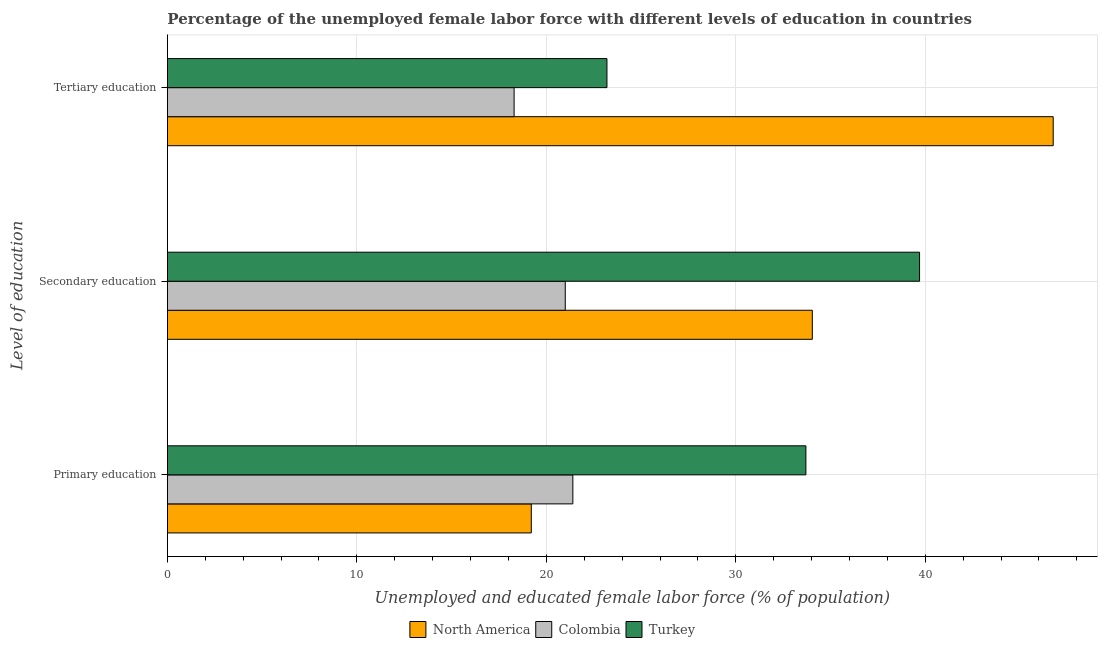How many groups of bars are there?
Your response must be concise. 3. Are the number of bars per tick equal to the number of legend labels?
Provide a short and direct response. Yes. Are the number of bars on each tick of the Y-axis equal?
Your answer should be compact. Yes. What is the label of the 2nd group of bars from the top?
Provide a short and direct response. Secondary education. What is the percentage of female labor force who received tertiary education in North America?
Keep it short and to the point. 46.75. Across all countries, what is the maximum percentage of female labor force who received secondary education?
Make the answer very short. 39.7. Across all countries, what is the minimum percentage of female labor force who received primary education?
Ensure brevity in your answer.  19.21. What is the total percentage of female labor force who received tertiary education in the graph?
Give a very brief answer. 88.25. What is the difference between the percentage of female labor force who received primary education in Colombia and that in North America?
Offer a terse response. 2.19. What is the difference between the percentage of female labor force who received secondary education in North America and the percentage of female labor force who received primary education in Colombia?
Your answer should be compact. 12.64. What is the average percentage of female labor force who received tertiary education per country?
Your response must be concise. 29.42. What is the difference between the percentage of female labor force who received secondary education and percentage of female labor force who received tertiary education in Turkey?
Provide a short and direct response. 16.5. In how many countries, is the percentage of female labor force who received tertiary education greater than 8 %?
Ensure brevity in your answer.  3. What is the ratio of the percentage of female labor force who received secondary education in North America to that in Turkey?
Make the answer very short. 0.86. Is the difference between the percentage of female labor force who received secondary education in Colombia and North America greater than the difference between the percentage of female labor force who received tertiary education in Colombia and North America?
Your answer should be compact. Yes. What is the difference between the highest and the second highest percentage of female labor force who received primary education?
Your response must be concise. 12.3. What is the difference between the highest and the lowest percentage of female labor force who received primary education?
Provide a short and direct response. 14.49. Is the sum of the percentage of female labor force who received secondary education in North America and Colombia greater than the maximum percentage of female labor force who received tertiary education across all countries?
Make the answer very short. Yes. What does the 1st bar from the bottom in Secondary education represents?
Offer a very short reply. North America. How are the legend labels stacked?
Provide a short and direct response. Horizontal. What is the title of the graph?
Provide a short and direct response. Percentage of the unemployed female labor force with different levels of education in countries. Does "Upper middle income" appear as one of the legend labels in the graph?
Provide a succinct answer. No. What is the label or title of the X-axis?
Ensure brevity in your answer.  Unemployed and educated female labor force (% of population). What is the label or title of the Y-axis?
Make the answer very short. Level of education. What is the Unemployed and educated female labor force (% of population) in North America in Primary education?
Provide a short and direct response. 19.21. What is the Unemployed and educated female labor force (% of population) in Colombia in Primary education?
Your answer should be very brief. 21.4. What is the Unemployed and educated female labor force (% of population) of Turkey in Primary education?
Make the answer very short. 33.7. What is the Unemployed and educated female labor force (% of population) of North America in Secondary education?
Offer a terse response. 34.04. What is the Unemployed and educated female labor force (% of population) in Colombia in Secondary education?
Provide a short and direct response. 21. What is the Unemployed and educated female labor force (% of population) of Turkey in Secondary education?
Your response must be concise. 39.7. What is the Unemployed and educated female labor force (% of population) in North America in Tertiary education?
Provide a short and direct response. 46.75. What is the Unemployed and educated female labor force (% of population) of Colombia in Tertiary education?
Your answer should be compact. 18.3. What is the Unemployed and educated female labor force (% of population) of Turkey in Tertiary education?
Your answer should be very brief. 23.2. Across all Level of education, what is the maximum Unemployed and educated female labor force (% of population) in North America?
Your answer should be very brief. 46.75. Across all Level of education, what is the maximum Unemployed and educated female labor force (% of population) in Colombia?
Provide a short and direct response. 21.4. Across all Level of education, what is the maximum Unemployed and educated female labor force (% of population) in Turkey?
Your answer should be compact. 39.7. Across all Level of education, what is the minimum Unemployed and educated female labor force (% of population) of North America?
Provide a succinct answer. 19.21. Across all Level of education, what is the minimum Unemployed and educated female labor force (% of population) in Colombia?
Your response must be concise. 18.3. Across all Level of education, what is the minimum Unemployed and educated female labor force (% of population) of Turkey?
Provide a short and direct response. 23.2. What is the total Unemployed and educated female labor force (% of population) of Colombia in the graph?
Your answer should be very brief. 60.7. What is the total Unemployed and educated female labor force (% of population) of Turkey in the graph?
Ensure brevity in your answer.  96.6. What is the difference between the Unemployed and educated female labor force (% of population) in North America in Primary education and that in Secondary education?
Give a very brief answer. -14.83. What is the difference between the Unemployed and educated female labor force (% of population) of North America in Primary education and that in Tertiary education?
Your answer should be compact. -27.55. What is the difference between the Unemployed and educated female labor force (% of population) in Colombia in Primary education and that in Tertiary education?
Your answer should be compact. 3.1. What is the difference between the Unemployed and educated female labor force (% of population) of North America in Secondary education and that in Tertiary education?
Offer a very short reply. -12.71. What is the difference between the Unemployed and educated female labor force (% of population) in Colombia in Secondary education and that in Tertiary education?
Offer a terse response. 2.7. What is the difference between the Unemployed and educated female labor force (% of population) in North America in Primary education and the Unemployed and educated female labor force (% of population) in Colombia in Secondary education?
Provide a short and direct response. -1.79. What is the difference between the Unemployed and educated female labor force (% of population) of North America in Primary education and the Unemployed and educated female labor force (% of population) of Turkey in Secondary education?
Give a very brief answer. -20.49. What is the difference between the Unemployed and educated female labor force (% of population) of Colombia in Primary education and the Unemployed and educated female labor force (% of population) of Turkey in Secondary education?
Make the answer very short. -18.3. What is the difference between the Unemployed and educated female labor force (% of population) of North America in Primary education and the Unemployed and educated female labor force (% of population) of Colombia in Tertiary education?
Give a very brief answer. 0.91. What is the difference between the Unemployed and educated female labor force (% of population) of North America in Primary education and the Unemployed and educated female labor force (% of population) of Turkey in Tertiary education?
Your response must be concise. -3.99. What is the difference between the Unemployed and educated female labor force (% of population) in Colombia in Primary education and the Unemployed and educated female labor force (% of population) in Turkey in Tertiary education?
Offer a very short reply. -1.8. What is the difference between the Unemployed and educated female labor force (% of population) in North America in Secondary education and the Unemployed and educated female labor force (% of population) in Colombia in Tertiary education?
Your answer should be very brief. 15.74. What is the difference between the Unemployed and educated female labor force (% of population) in North America in Secondary education and the Unemployed and educated female labor force (% of population) in Turkey in Tertiary education?
Provide a short and direct response. 10.84. What is the average Unemployed and educated female labor force (% of population) in North America per Level of education?
Your response must be concise. 33.33. What is the average Unemployed and educated female labor force (% of population) in Colombia per Level of education?
Your response must be concise. 20.23. What is the average Unemployed and educated female labor force (% of population) in Turkey per Level of education?
Your response must be concise. 32.2. What is the difference between the Unemployed and educated female labor force (% of population) of North America and Unemployed and educated female labor force (% of population) of Colombia in Primary education?
Your answer should be very brief. -2.19. What is the difference between the Unemployed and educated female labor force (% of population) in North America and Unemployed and educated female labor force (% of population) in Turkey in Primary education?
Provide a succinct answer. -14.49. What is the difference between the Unemployed and educated female labor force (% of population) in North America and Unemployed and educated female labor force (% of population) in Colombia in Secondary education?
Provide a succinct answer. 13.04. What is the difference between the Unemployed and educated female labor force (% of population) in North America and Unemployed and educated female labor force (% of population) in Turkey in Secondary education?
Provide a succinct answer. -5.66. What is the difference between the Unemployed and educated female labor force (% of population) of Colombia and Unemployed and educated female labor force (% of population) of Turkey in Secondary education?
Offer a terse response. -18.7. What is the difference between the Unemployed and educated female labor force (% of population) in North America and Unemployed and educated female labor force (% of population) in Colombia in Tertiary education?
Ensure brevity in your answer.  28.45. What is the difference between the Unemployed and educated female labor force (% of population) of North America and Unemployed and educated female labor force (% of population) of Turkey in Tertiary education?
Offer a very short reply. 23.55. What is the ratio of the Unemployed and educated female labor force (% of population) in North America in Primary education to that in Secondary education?
Your answer should be very brief. 0.56. What is the ratio of the Unemployed and educated female labor force (% of population) in Turkey in Primary education to that in Secondary education?
Provide a short and direct response. 0.85. What is the ratio of the Unemployed and educated female labor force (% of population) in North America in Primary education to that in Tertiary education?
Your answer should be very brief. 0.41. What is the ratio of the Unemployed and educated female labor force (% of population) of Colombia in Primary education to that in Tertiary education?
Provide a succinct answer. 1.17. What is the ratio of the Unemployed and educated female labor force (% of population) in Turkey in Primary education to that in Tertiary education?
Your response must be concise. 1.45. What is the ratio of the Unemployed and educated female labor force (% of population) in North America in Secondary education to that in Tertiary education?
Make the answer very short. 0.73. What is the ratio of the Unemployed and educated female labor force (% of population) in Colombia in Secondary education to that in Tertiary education?
Your answer should be very brief. 1.15. What is the ratio of the Unemployed and educated female labor force (% of population) in Turkey in Secondary education to that in Tertiary education?
Your answer should be compact. 1.71. What is the difference between the highest and the second highest Unemployed and educated female labor force (% of population) of North America?
Offer a very short reply. 12.71. What is the difference between the highest and the second highest Unemployed and educated female labor force (% of population) in Colombia?
Provide a short and direct response. 0.4. What is the difference between the highest and the lowest Unemployed and educated female labor force (% of population) in North America?
Your response must be concise. 27.55. What is the difference between the highest and the lowest Unemployed and educated female labor force (% of population) in Colombia?
Keep it short and to the point. 3.1. 